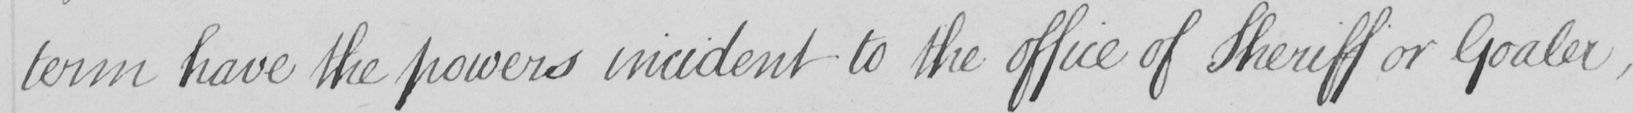What is written in this line of handwriting? term have the powers incident to the office of Sheriff or Goaler , 